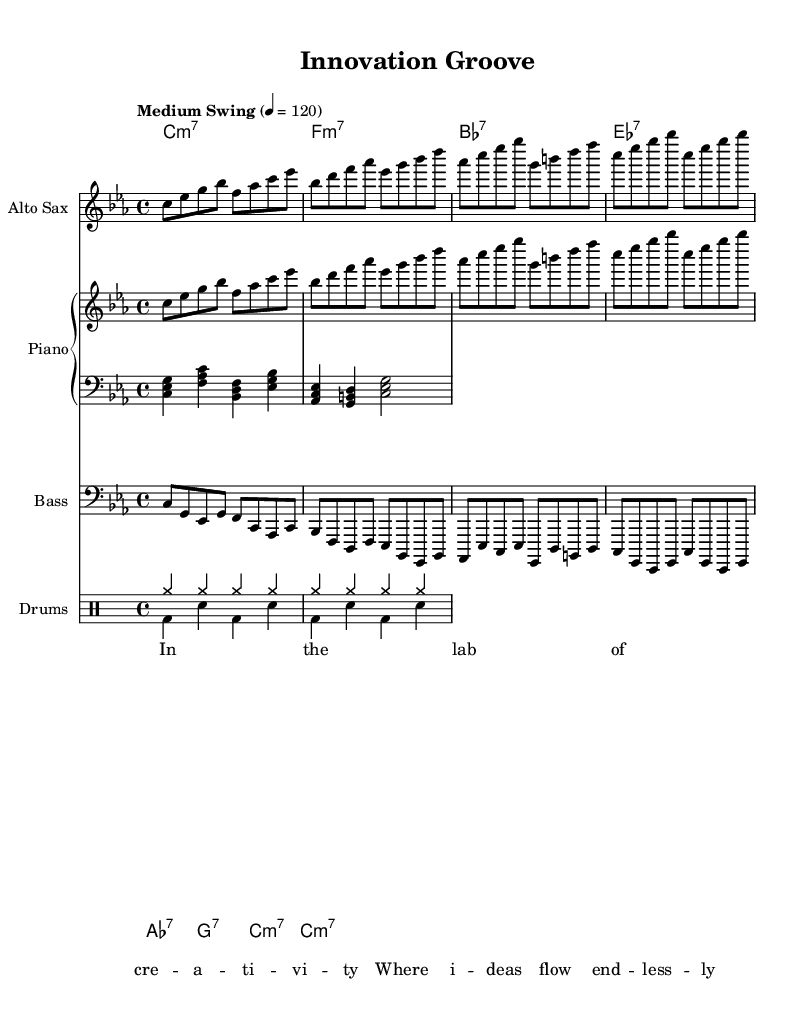What is the key signature of this music? The key signature is C minor, which has three flats (B flat, E flat, and A flat). This can be determined by looking at the key signature indicated at the beginning of the sheet music.
Answer: C minor What is the time signature of this music? The time signature is 4/4, meaning there are four beats in each measure, and the quarter note gets one beat. This is displayed at the beginning of the score right after the key signature.
Answer: 4/4 What is the tempo marking for this piece? The tempo marking is "Medium Swing" with a metronome marking of 120. This indicates that the piece should be played with a medium swing feel at a speed of 120 beats per minute.
Answer: Medium Swing, 120 How many unique sections are there in the score? There are five unique sections in the score: ChordNames, Alto Sax, Piano (which has right-hand and left-hand parts), Bass, and Drums. We can count the number of distinct musical groups indicated in the score layout.
Answer: Five What is the lyric theme present in this piece? The lyrics focus on creativity and innovation, as shown in the text quoting "In the lab of creativity where ideas flow endlessly." This reflects the theme of the song focusing on a creative process.
Answer: Creativity and innovation Which instrument plays the melody? The instrument playing the melody is the Alto Sax. This is determined by looking at the staff labeled "Alto Sax" in the score, where the melody notes are written.
Answer: Alto Sax What type of accompaniment does the piano provide? The piano provides a harmonic accompaniment with both right-hand chords and left-hand bass notes. The right hand plays melody-like figures while the left hand maintains the harmonic structure, characteristic of jazz fusion.
Answer: Harmonic accompaniment 